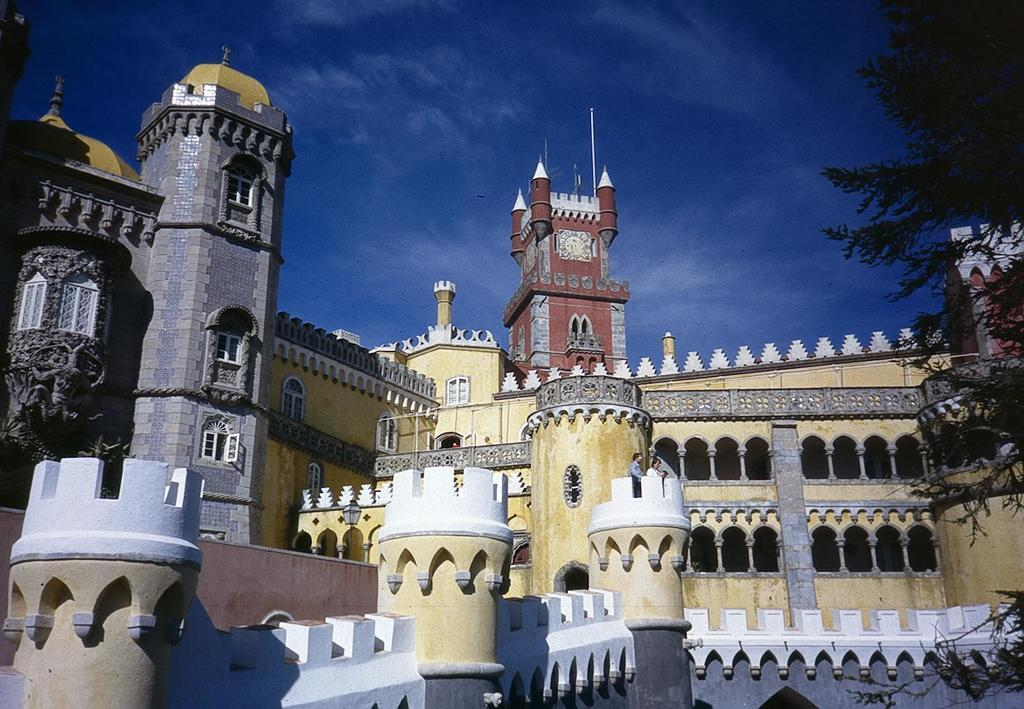What type of structures can be seen in the image? There are buildings in the image. Can you describe a specific detail about one of the buildings? There is a clock on a building in the background. What type of vegetation is on the right side of the image? There are trees on the right side of the image. What can be seen in the sky at the top of the image? There are clouds visible in the sky at the top of the image. What is the father's role in the image? There is no father present in the image. What is the tendency of the silver objects in the image? There are no silver objects present in the image. 